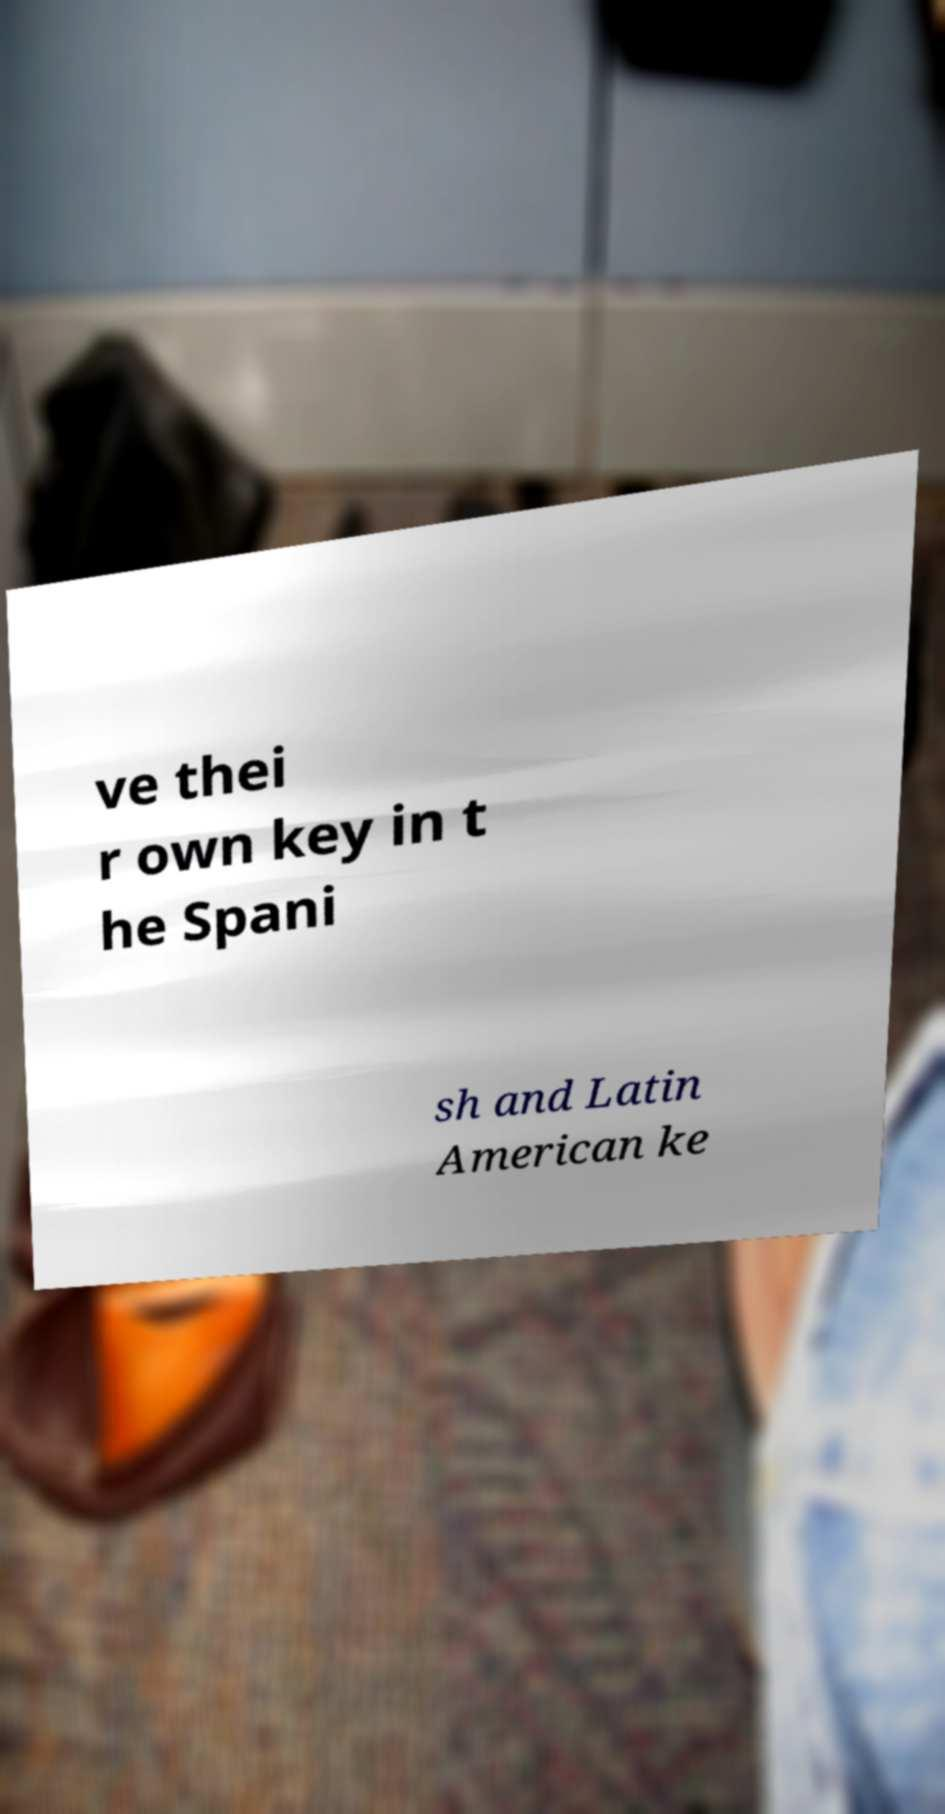Please read and relay the text visible in this image. What does it say? ve thei r own key in t he Spani sh and Latin American ke 